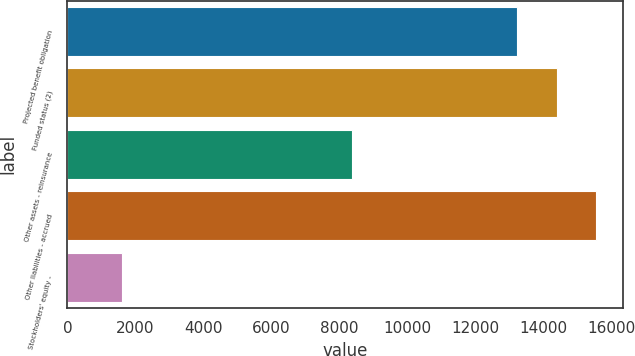Convert chart to OTSL. <chart><loc_0><loc_0><loc_500><loc_500><bar_chart><fcel>Projected benefit obligation<fcel>Funded status (2)<fcel>Other assets - reinsurance<fcel>Other liabilities - accrued<fcel>Stockholders' equity -<nl><fcel>13224<fcel>14386.2<fcel>8380<fcel>15548.4<fcel>1602<nl></chart> 